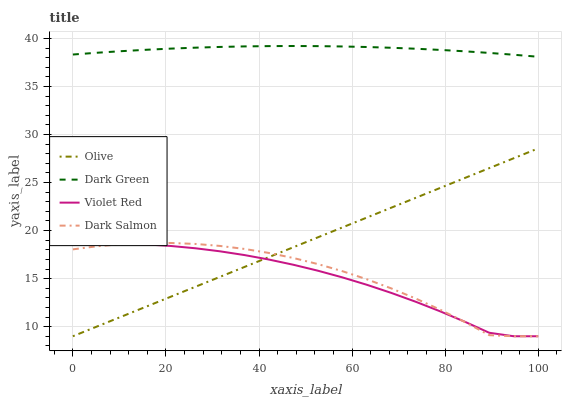Does Violet Red have the minimum area under the curve?
Answer yes or no. Yes. Does Dark Green have the maximum area under the curve?
Answer yes or no. Yes. Does Dark Salmon have the minimum area under the curve?
Answer yes or no. No. Does Dark Salmon have the maximum area under the curve?
Answer yes or no. No. Is Olive the smoothest?
Answer yes or no. Yes. Is Dark Salmon the roughest?
Answer yes or no. Yes. Is Violet Red the smoothest?
Answer yes or no. No. Is Violet Red the roughest?
Answer yes or no. No. Does Dark Green have the lowest value?
Answer yes or no. No. Does Dark Salmon have the highest value?
Answer yes or no. No. Is Dark Salmon less than Dark Green?
Answer yes or no. Yes. Is Dark Green greater than Olive?
Answer yes or no. Yes. Does Dark Salmon intersect Dark Green?
Answer yes or no. No. 